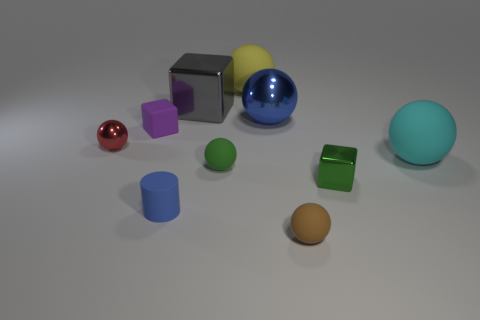What color is the big cube?
Provide a succinct answer. Gray. What number of metal things are either green balls or big brown cylinders?
Your response must be concise. 0. The tiny metal object that is the same shape as the small brown rubber thing is what color?
Offer a terse response. Red. Are there any gray things?
Your response must be concise. Yes. Is the big ball that is in front of the red object made of the same material as the blue thing that is behind the tiny green shiny object?
Provide a succinct answer. No. What shape is the metallic thing that is the same color as the rubber cylinder?
Make the answer very short. Sphere. What number of things are metallic cubes behind the cyan matte sphere or rubber things that are behind the brown thing?
Make the answer very short. 6. Do the metal block in front of the cyan thing and the small matte ball behind the tiny metallic cube have the same color?
Your answer should be compact. Yes. What shape is the tiny rubber object that is left of the big gray object and behind the green shiny object?
Provide a short and direct response. Cube. What color is the cylinder that is the same size as the brown rubber thing?
Give a very brief answer. Blue. 